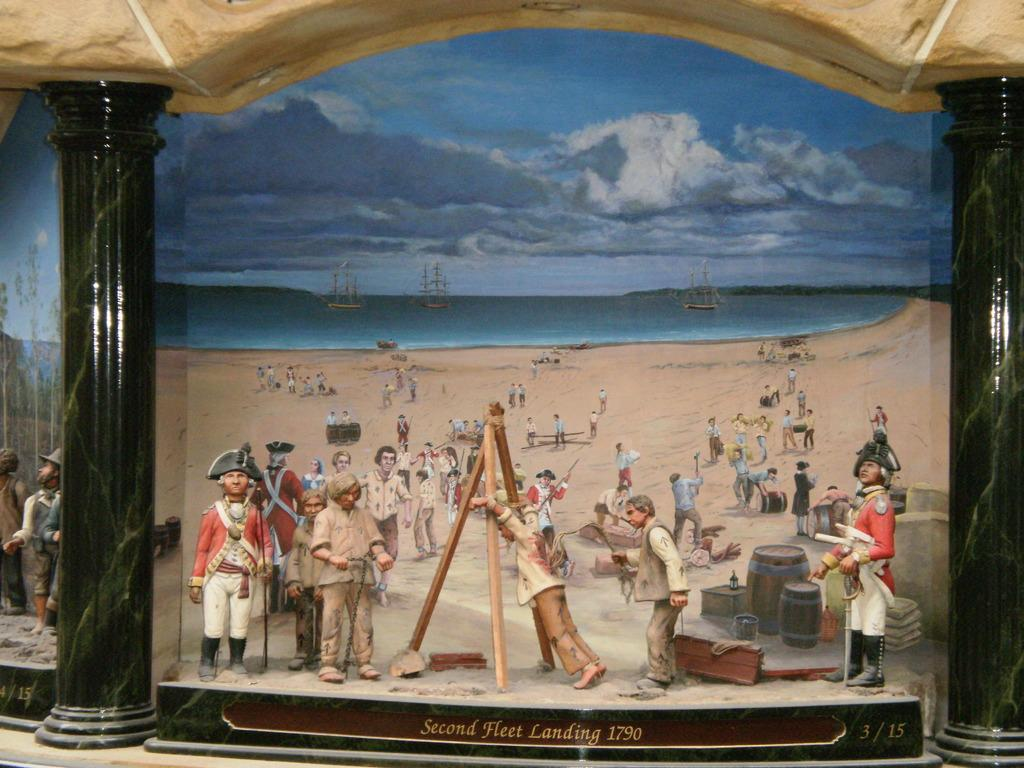Provide a one-sentence caption for the provided image. An art exhibit showing the second fleet landing in the year 1790. 